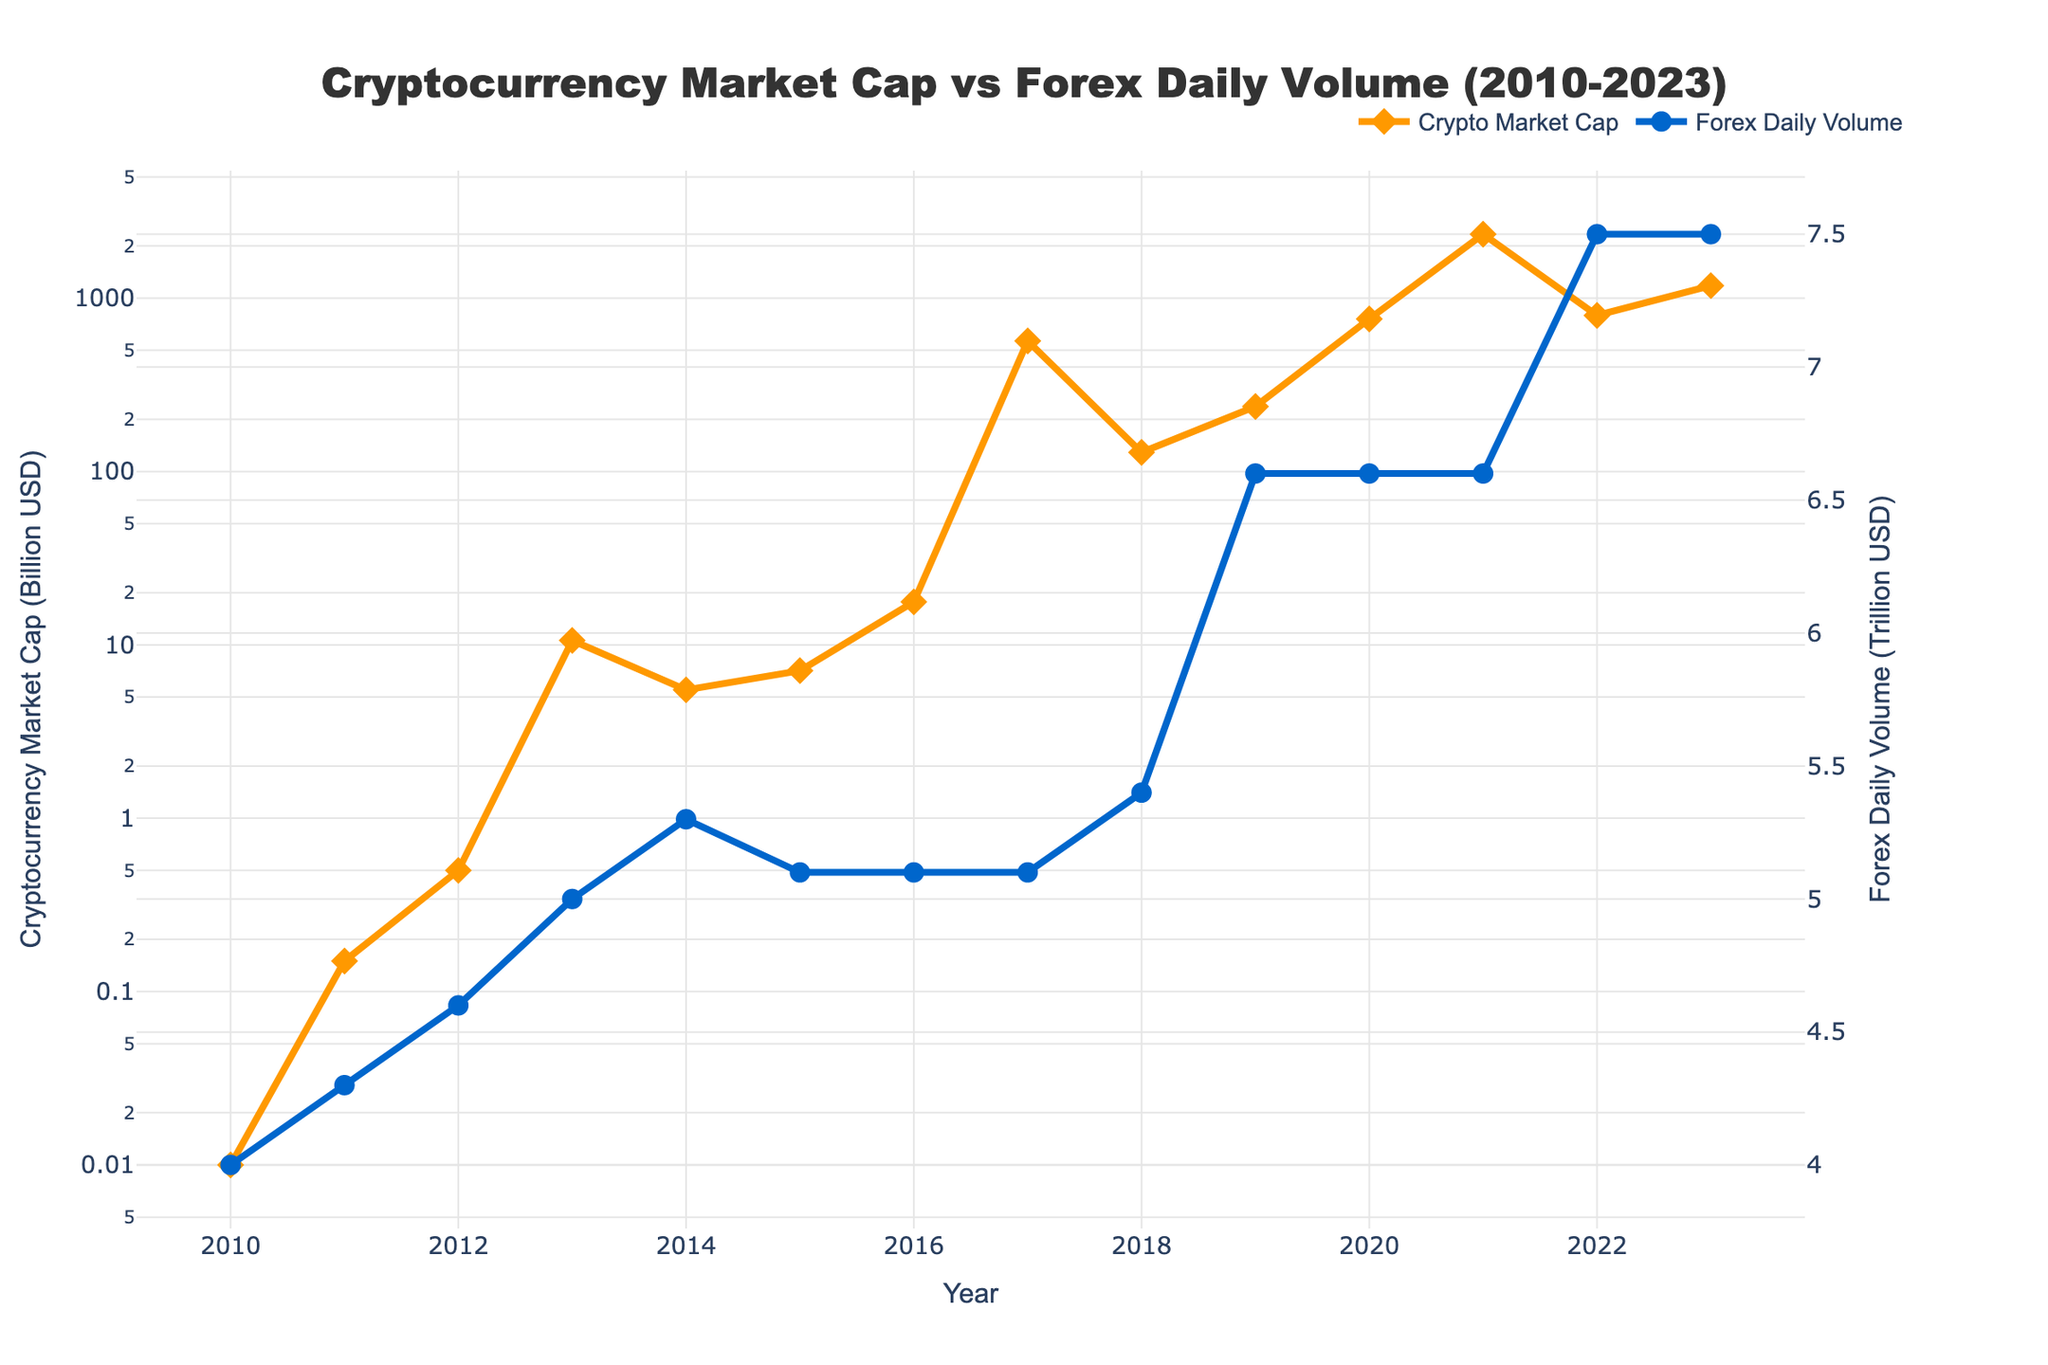What was the cryptocurrency market cap in 2013? In 2013, the point for "Cryptocurrency Market Cap" on the Y-axis reads 10.6 Billion USD.
Answer: 10.6 Billion USD How does the Forex daily volume in 2022 compare to 2010? In 2022, the Forex daily volume is 7.5 Trillion USD. In 2010, it was 4.0 Trillion USD. So, 7.5 - 4.0 = 3.5 Trillion USD higher in 2022.
Answer: 3.5 Trillion USD higher Which year experienced the highest cryptocurrency market capitalization, and what was the value? The highest peak for the "Cryptocurrency Market Cap" on the Y-axis is in 2021, with the value reaching 2338 Billion USD.
Answer: 2021, 2338 Billion USD In which years did the cryptocurrency market cap significantly decline? There are clear declines in the plot for cryptocurrency market cap between 2013 and 2014, as well as between 2021 and 2022.
Answer: 2013-2014 and 2021-2022 What is the average Forex daily volume from 2017 to 2023? Add Forex daily volume for 2017-2023: 5.1 + 5.4 + 6.6 + 6.6 + 6.6 + 7.5 + 7.5 = 45.3 Trillion USD. There are 7 years, so average = 45.3 / 7 = 6.47 Trillion USD.
Answer: 6.47 Trillion USD Compare the cryptocurrency market cap in 2017 and 2019. In 2017, the market cap is 566.3 Billion USD, and in 2019, it is 237.1 Billion USD. So, the market cap in 2017 is higher by 566.3 - 237.1 = 329.2 Billion USD.
Answer: 329.2 Billion USD higher in 2017 What is the overall trend in Forex daily volume from 2010 to 2023? The Forex daily volume shows a generally increasing trend, starting at 4.0 Trillion USD in 2010 and ending at 7.5 Trillion USD in 2023.
Answer: Increasing By what factor did the cryptocurrency market cap increase from 2012 to 2021? In 2012, the market cap was 0.5 Billion USD, and in 2021, it was 2338 Billion USD. The factor is 2338 / 0.5, which is 4676.
Answer: 4676 How much did the cryptocurrency market cap decrease from 2021 to 2022? In 2021, it was 2338 Billion USD, and in 2022, it was 795 Billion USD. It decreased by 2338 - 795 = 1543 Billion USD.
Answer: 1543 Billion USD Describe the color coding used for the cryptocurrency market cap and Forex daily volume in the chart. The cryptocurrency market cap is represented by an orange line with diamond markers, and the Forex daily volume is represented by a blue line with circle markers.
Answer: Orange for crypto, blue for Forex 